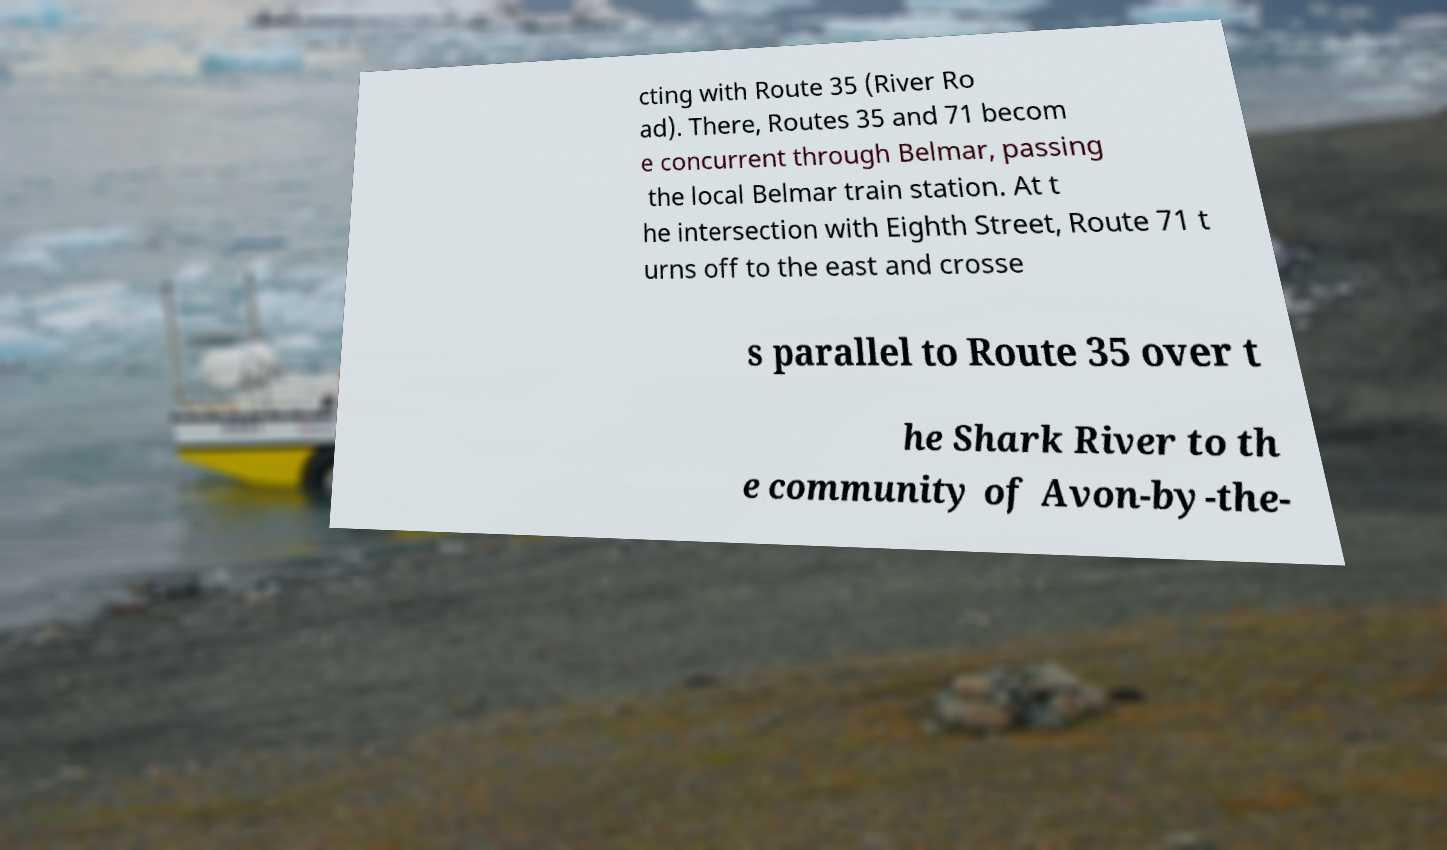I need the written content from this picture converted into text. Can you do that? cting with Route 35 (River Ro ad). There, Routes 35 and 71 becom e concurrent through Belmar, passing the local Belmar train station. At t he intersection with Eighth Street, Route 71 t urns off to the east and crosse s parallel to Route 35 over t he Shark River to th e community of Avon-by-the- 